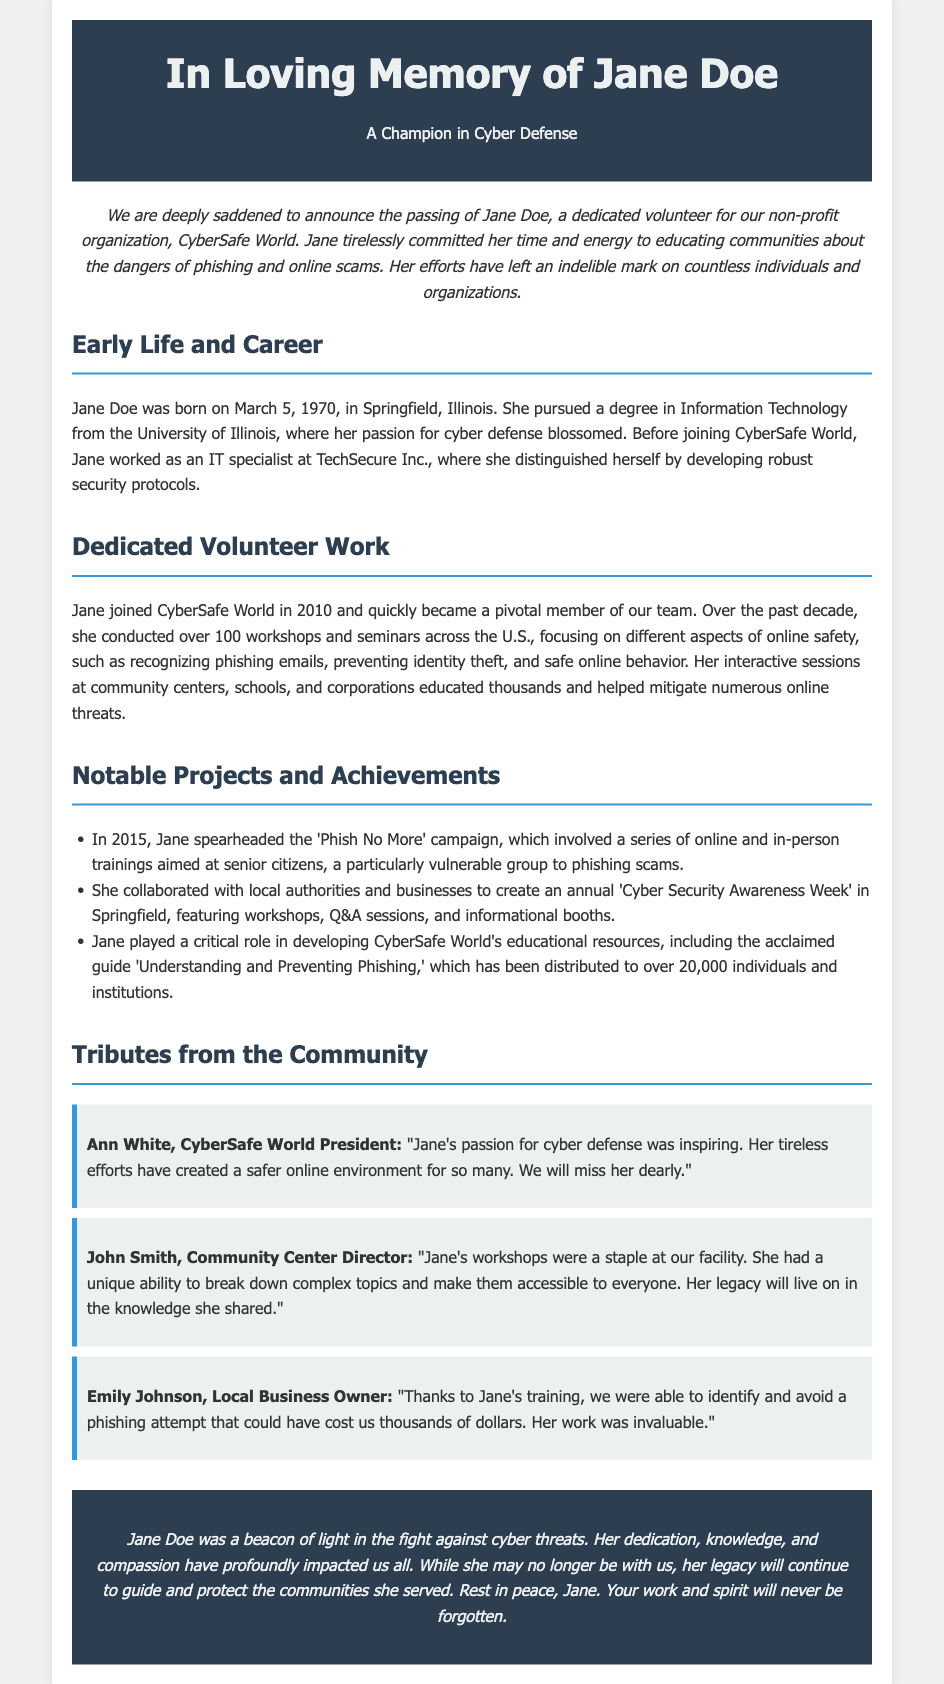What was Jane Doe's profession before joining CyberSafe World? Jane worked as an IT specialist at TechSecure Inc. before joining CyberSafe World.
Answer: IT specialist When was the 'Phish No More' campaign initiated? The campaign was spearheaded by Jane in 2015.
Answer: 2015 How many workshops did Jane conduct over the past decade? The document states that Jane conducted over 100 workshops across the U.S.
Answer: 100 What degree did Jane earn from the University of Illinois? Jane pursued a degree in Information Technology.
Answer: Information Technology Who is the President of CyberSafe World that paid tribute to Jane? Ann White is mentioned as the President who honored Jane in her tribute.
Answer: Ann White What impact did Jane's training have on Emily Johnson's business? Emily's business was able to identify and avoid a phishing attempt due to Jane's training.
Answer: Identify and avoid phishing attempt What was the focus of Jane's workshops? Jane's workshops focused on different aspects of online safety, such as recognizing phishing emails.
Answer: Online safety What year did Jane join CyberSafe World? Jane became a member of CyberSafe World in 2010.
Answer: 2010 How did the community perceive Jane’s ability to educate others? John Smith stated she had a unique ability to break down complex topics and make them accessible.
Answer: Unique ability 